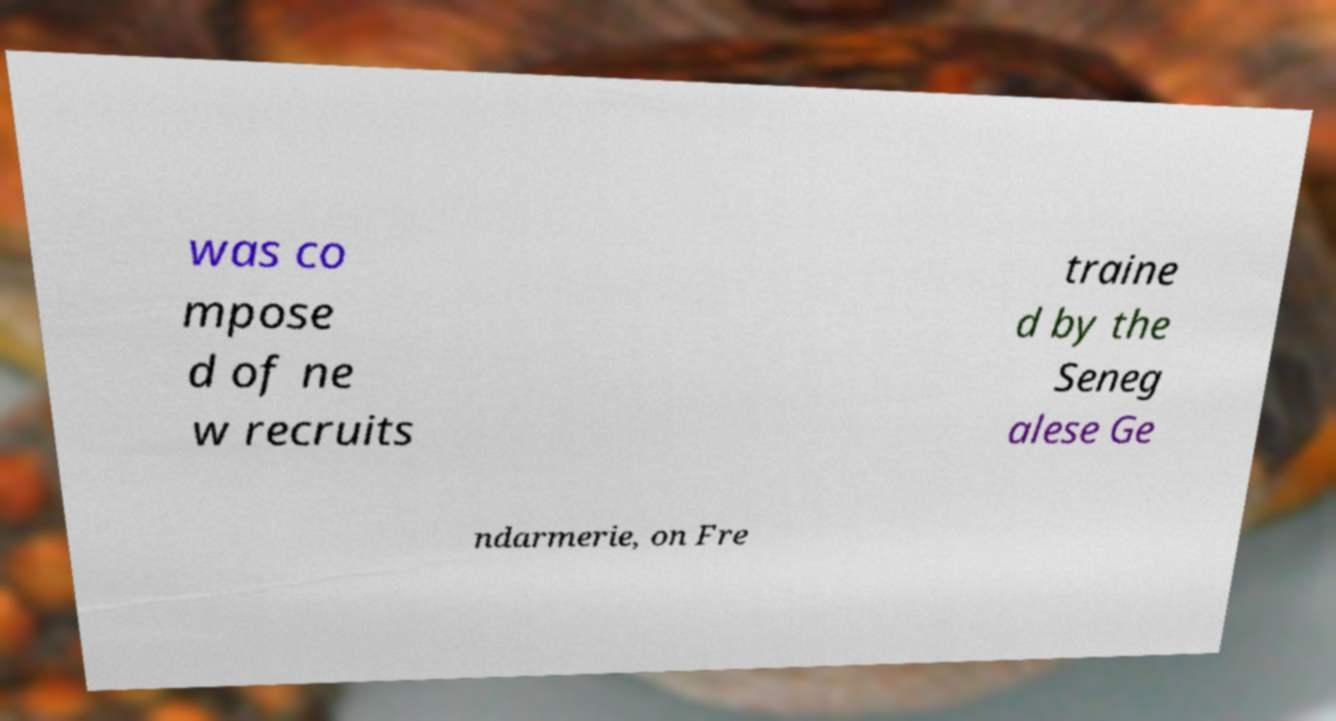I need the written content from this picture converted into text. Can you do that? was co mpose d of ne w recruits traine d by the Seneg alese Ge ndarmerie, on Fre 